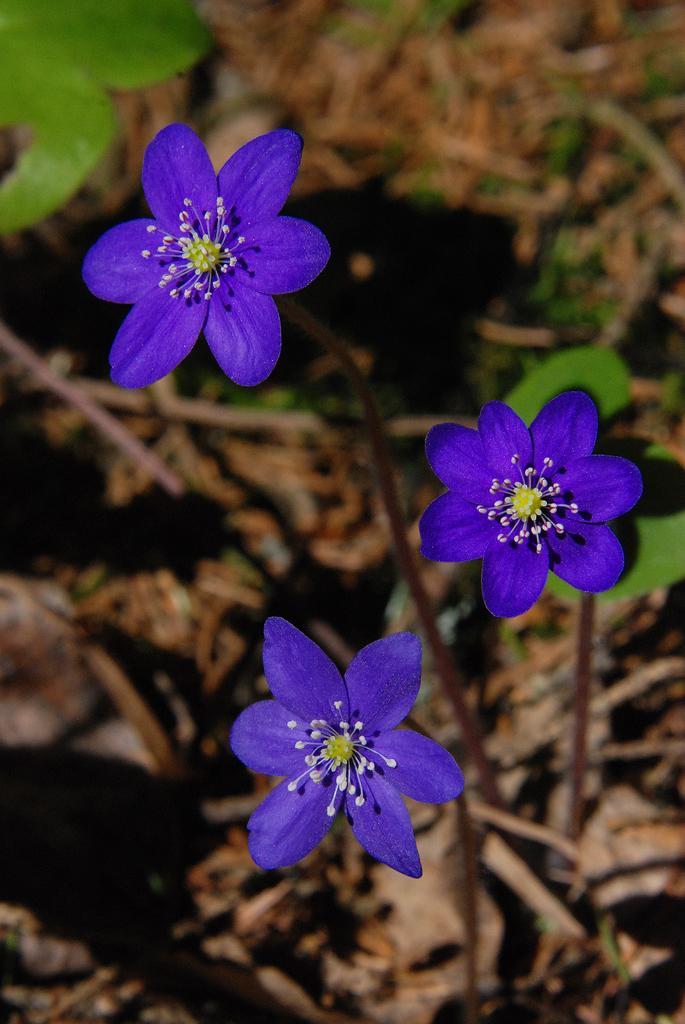Describe this image in one or two sentences. In this image, in the middle, we can see a flower which is in blue color. On the right side, we can also see a flower which is in blue color with green leaves. On the left side, we can see a flower which is in blue color. In the left corner, we can also see green leaves. In the background, we can see a land. 